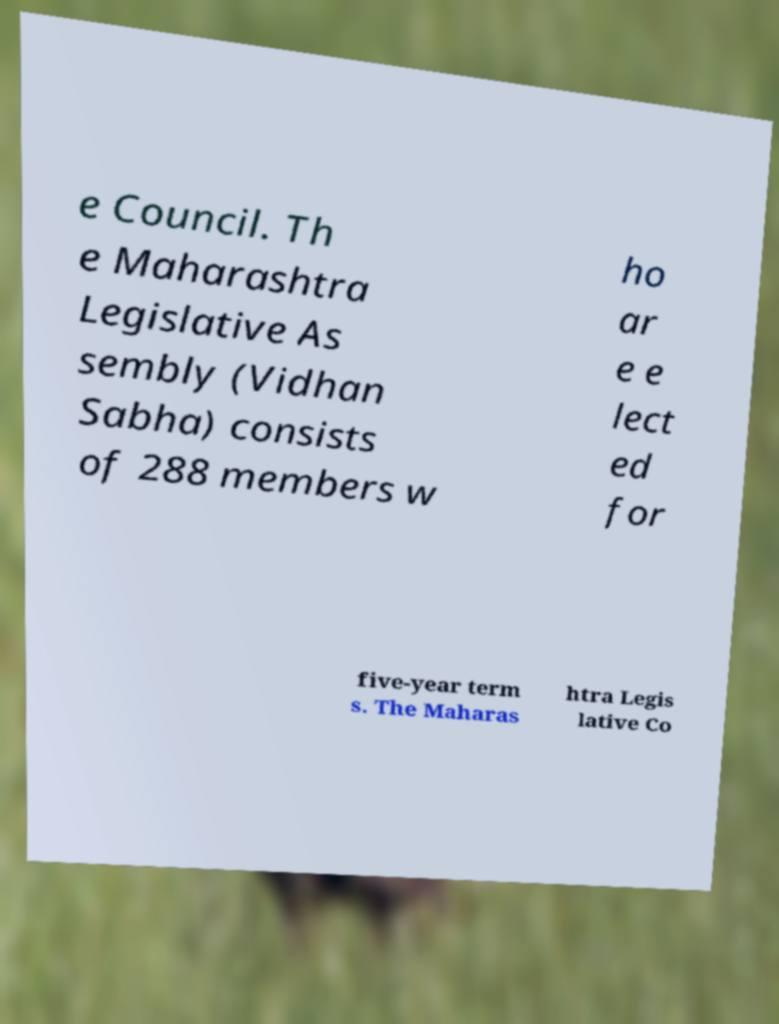For documentation purposes, I need the text within this image transcribed. Could you provide that? e Council. Th e Maharashtra Legislative As sembly (Vidhan Sabha) consists of 288 members w ho ar e e lect ed for five-year term s. The Maharas htra Legis lative Co 